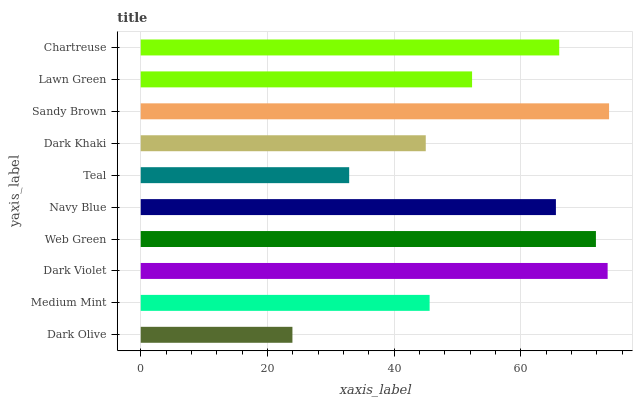Is Dark Olive the minimum?
Answer yes or no. Yes. Is Sandy Brown the maximum?
Answer yes or no. Yes. Is Medium Mint the minimum?
Answer yes or no. No. Is Medium Mint the maximum?
Answer yes or no. No. Is Medium Mint greater than Dark Olive?
Answer yes or no. Yes. Is Dark Olive less than Medium Mint?
Answer yes or no. Yes. Is Dark Olive greater than Medium Mint?
Answer yes or no. No. Is Medium Mint less than Dark Olive?
Answer yes or no. No. Is Navy Blue the high median?
Answer yes or no. Yes. Is Lawn Green the low median?
Answer yes or no. Yes. Is Dark Khaki the high median?
Answer yes or no. No. Is Dark Violet the low median?
Answer yes or no. No. 